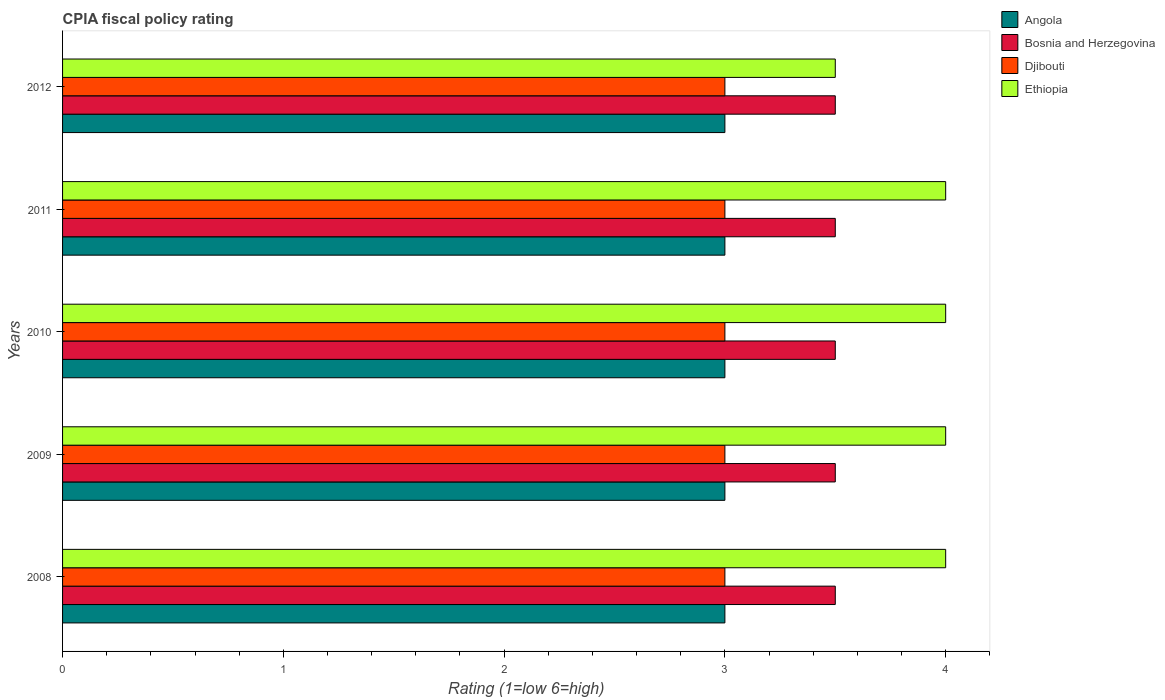How many different coloured bars are there?
Offer a terse response. 4. Are the number of bars per tick equal to the number of legend labels?
Your response must be concise. Yes. Are the number of bars on each tick of the Y-axis equal?
Your answer should be very brief. Yes. How many bars are there on the 5th tick from the top?
Provide a succinct answer. 4. How many bars are there on the 4th tick from the bottom?
Your answer should be compact. 4. What is the label of the 5th group of bars from the top?
Provide a short and direct response. 2008. What is the CPIA rating in Djibouti in 2012?
Provide a succinct answer. 3. Across all years, what is the maximum CPIA rating in Ethiopia?
Offer a very short reply. 4. In which year was the CPIA rating in Djibouti minimum?
Provide a short and direct response. 2008. What is the difference between the CPIA rating in Djibouti in 2010 and that in 2012?
Give a very brief answer. 0. What is the difference between the CPIA rating in Angola in 2009 and the CPIA rating in Ethiopia in 2008?
Offer a terse response. -1. What is the average CPIA rating in Angola per year?
Your response must be concise. 3. In how many years, is the CPIA rating in Djibouti greater than 3.2 ?
Make the answer very short. 0. Is the difference between the CPIA rating in Angola in 2008 and 2011 greater than the difference between the CPIA rating in Ethiopia in 2008 and 2011?
Make the answer very short. No. What is the difference between the highest and the second highest CPIA rating in Ethiopia?
Offer a very short reply. 0. What is the difference between the highest and the lowest CPIA rating in Angola?
Keep it short and to the point. 0. In how many years, is the CPIA rating in Bosnia and Herzegovina greater than the average CPIA rating in Bosnia and Herzegovina taken over all years?
Your response must be concise. 0. Is it the case that in every year, the sum of the CPIA rating in Angola and CPIA rating in Djibouti is greater than the sum of CPIA rating in Ethiopia and CPIA rating in Bosnia and Herzegovina?
Your answer should be compact. No. What does the 1st bar from the top in 2008 represents?
Your answer should be compact. Ethiopia. What does the 3rd bar from the bottom in 2012 represents?
Make the answer very short. Djibouti. Is it the case that in every year, the sum of the CPIA rating in Angola and CPIA rating in Ethiopia is greater than the CPIA rating in Bosnia and Herzegovina?
Your response must be concise. Yes. How many years are there in the graph?
Make the answer very short. 5. What is the difference between two consecutive major ticks on the X-axis?
Your answer should be very brief. 1. How many legend labels are there?
Offer a terse response. 4. What is the title of the graph?
Ensure brevity in your answer.  CPIA fiscal policy rating. Does "Papua New Guinea" appear as one of the legend labels in the graph?
Keep it short and to the point. No. What is the label or title of the X-axis?
Your answer should be compact. Rating (1=low 6=high). What is the Rating (1=low 6=high) of Angola in 2008?
Offer a terse response. 3. What is the Rating (1=low 6=high) in Angola in 2009?
Provide a short and direct response. 3. What is the Rating (1=low 6=high) in Djibouti in 2010?
Your answer should be compact. 3. What is the Rating (1=low 6=high) in Ethiopia in 2010?
Provide a short and direct response. 4. What is the Rating (1=low 6=high) of Angola in 2011?
Your answer should be very brief. 3. What is the Rating (1=low 6=high) of Djibouti in 2011?
Keep it short and to the point. 3. What is the Rating (1=low 6=high) in Angola in 2012?
Your response must be concise. 3. What is the Rating (1=low 6=high) of Djibouti in 2012?
Offer a very short reply. 3. Across all years, what is the maximum Rating (1=low 6=high) in Bosnia and Herzegovina?
Give a very brief answer. 3.5. Across all years, what is the maximum Rating (1=low 6=high) in Djibouti?
Make the answer very short. 3. Across all years, what is the minimum Rating (1=low 6=high) of Angola?
Keep it short and to the point. 3. Across all years, what is the minimum Rating (1=low 6=high) of Bosnia and Herzegovina?
Provide a short and direct response. 3.5. Across all years, what is the minimum Rating (1=low 6=high) in Djibouti?
Your answer should be compact. 3. Across all years, what is the minimum Rating (1=low 6=high) of Ethiopia?
Provide a succinct answer. 3.5. What is the total Rating (1=low 6=high) in Bosnia and Herzegovina in the graph?
Your answer should be compact. 17.5. What is the total Rating (1=low 6=high) in Djibouti in the graph?
Your response must be concise. 15. What is the difference between the Rating (1=low 6=high) in Ethiopia in 2008 and that in 2009?
Your response must be concise. 0. What is the difference between the Rating (1=low 6=high) in Angola in 2008 and that in 2010?
Keep it short and to the point. 0. What is the difference between the Rating (1=low 6=high) of Bosnia and Herzegovina in 2008 and that in 2010?
Ensure brevity in your answer.  0. What is the difference between the Rating (1=low 6=high) in Angola in 2008 and that in 2011?
Make the answer very short. 0. What is the difference between the Rating (1=low 6=high) of Djibouti in 2008 and that in 2012?
Give a very brief answer. 0. What is the difference between the Rating (1=low 6=high) of Ethiopia in 2008 and that in 2012?
Give a very brief answer. 0.5. What is the difference between the Rating (1=low 6=high) of Bosnia and Herzegovina in 2009 and that in 2010?
Provide a succinct answer. 0. What is the difference between the Rating (1=low 6=high) in Djibouti in 2009 and that in 2010?
Your response must be concise. 0. What is the difference between the Rating (1=low 6=high) of Ethiopia in 2009 and that in 2010?
Your answer should be compact. 0. What is the difference between the Rating (1=low 6=high) of Angola in 2009 and that in 2011?
Your answer should be compact. 0. What is the difference between the Rating (1=low 6=high) of Bosnia and Herzegovina in 2009 and that in 2011?
Provide a short and direct response. 0. What is the difference between the Rating (1=low 6=high) of Ethiopia in 2009 and that in 2012?
Your answer should be compact. 0.5. What is the difference between the Rating (1=low 6=high) in Angola in 2010 and that in 2011?
Give a very brief answer. 0. What is the difference between the Rating (1=low 6=high) of Djibouti in 2010 and that in 2011?
Your answer should be very brief. 0. What is the difference between the Rating (1=low 6=high) of Angola in 2010 and that in 2012?
Your answer should be compact. 0. What is the difference between the Rating (1=low 6=high) of Djibouti in 2011 and that in 2012?
Ensure brevity in your answer.  0. What is the difference between the Rating (1=low 6=high) of Ethiopia in 2011 and that in 2012?
Give a very brief answer. 0.5. What is the difference between the Rating (1=low 6=high) in Angola in 2008 and the Rating (1=low 6=high) in Bosnia and Herzegovina in 2009?
Your answer should be very brief. -0.5. What is the difference between the Rating (1=low 6=high) of Angola in 2008 and the Rating (1=low 6=high) of Djibouti in 2009?
Give a very brief answer. 0. What is the difference between the Rating (1=low 6=high) in Bosnia and Herzegovina in 2008 and the Rating (1=low 6=high) in Djibouti in 2009?
Your answer should be very brief. 0.5. What is the difference between the Rating (1=low 6=high) of Angola in 2008 and the Rating (1=low 6=high) of Djibouti in 2010?
Give a very brief answer. 0. What is the difference between the Rating (1=low 6=high) in Angola in 2008 and the Rating (1=low 6=high) in Ethiopia in 2010?
Offer a terse response. -1. What is the difference between the Rating (1=low 6=high) in Angola in 2008 and the Rating (1=low 6=high) in Djibouti in 2011?
Keep it short and to the point. 0. What is the difference between the Rating (1=low 6=high) of Bosnia and Herzegovina in 2008 and the Rating (1=low 6=high) of Djibouti in 2011?
Make the answer very short. 0.5. What is the difference between the Rating (1=low 6=high) of Bosnia and Herzegovina in 2008 and the Rating (1=low 6=high) of Ethiopia in 2011?
Provide a short and direct response. -0.5. What is the difference between the Rating (1=low 6=high) in Angola in 2008 and the Rating (1=low 6=high) in Bosnia and Herzegovina in 2012?
Offer a terse response. -0.5. What is the difference between the Rating (1=low 6=high) of Angola in 2008 and the Rating (1=low 6=high) of Ethiopia in 2012?
Your answer should be very brief. -0.5. What is the difference between the Rating (1=low 6=high) in Djibouti in 2008 and the Rating (1=low 6=high) in Ethiopia in 2012?
Provide a succinct answer. -0.5. What is the difference between the Rating (1=low 6=high) in Angola in 2009 and the Rating (1=low 6=high) in Ethiopia in 2010?
Provide a short and direct response. -1. What is the difference between the Rating (1=low 6=high) in Djibouti in 2009 and the Rating (1=low 6=high) in Ethiopia in 2010?
Your answer should be very brief. -1. What is the difference between the Rating (1=low 6=high) in Bosnia and Herzegovina in 2009 and the Rating (1=low 6=high) in Djibouti in 2011?
Give a very brief answer. 0.5. What is the difference between the Rating (1=low 6=high) of Bosnia and Herzegovina in 2009 and the Rating (1=low 6=high) of Ethiopia in 2011?
Provide a succinct answer. -0.5. What is the difference between the Rating (1=low 6=high) in Djibouti in 2009 and the Rating (1=low 6=high) in Ethiopia in 2011?
Offer a very short reply. -1. What is the difference between the Rating (1=low 6=high) in Angola in 2009 and the Rating (1=low 6=high) in Djibouti in 2012?
Offer a very short reply. 0. What is the difference between the Rating (1=low 6=high) of Bosnia and Herzegovina in 2009 and the Rating (1=low 6=high) of Ethiopia in 2012?
Your response must be concise. 0. What is the difference between the Rating (1=low 6=high) of Djibouti in 2009 and the Rating (1=low 6=high) of Ethiopia in 2012?
Your answer should be compact. -0.5. What is the difference between the Rating (1=low 6=high) of Angola in 2010 and the Rating (1=low 6=high) of Djibouti in 2011?
Ensure brevity in your answer.  0. What is the difference between the Rating (1=low 6=high) of Bosnia and Herzegovina in 2010 and the Rating (1=low 6=high) of Ethiopia in 2011?
Offer a very short reply. -0.5. What is the difference between the Rating (1=low 6=high) in Angola in 2010 and the Rating (1=low 6=high) in Bosnia and Herzegovina in 2012?
Provide a succinct answer. -0.5. What is the difference between the Rating (1=low 6=high) in Bosnia and Herzegovina in 2010 and the Rating (1=low 6=high) in Djibouti in 2012?
Offer a very short reply. 0.5. What is the difference between the Rating (1=low 6=high) in Angola in 2011 and the Rating (1=low 6=high) in Bosnia and Herzegovina in 2012?
Your answer should be compact. -0.5. What is the difference between the Rating (1=low 6=high) of Angola in 2011 and the Rating (1=low 6=high) of Ethiopia in 2012?
Your response must be concise. -0.5. What is the difference between the Rating (1=low 6=high) of Bosnia and Herzegovina in 2011 and the Rating (1=low 6=high) of Ethiopia in 2012?
Make the answer very short. 0. What is the difference between the Rating (1=low 6=high) in Djibouti in 2011 and the Rating (1=low 6=high) in Ethiopia in 2012?
Give a very brief answer. -0.5. In the year 2008, what is the difference between the Rating (1=low 6=high) of Angola and Rating (1=low 6=high) of Bosnia and Herzegovina?
Provide a succinct answer. -0.5. In the year 2008, what is the difference between the Rating (1=low 6=high) in Angola and Rating (1=low 6=high) in Djibouti?
Make the answer very short. 0. In the year 2008, what is the difference between the Rating (1=low 6=high) of Bosnia and Herzegovina and Rating (1=low 6=high) of Djibouti?
Give a very brief answer. 0.5. In the year 2008, what is the difference between the Rating (1=low 6=high) of Djibouti and Rating (1=low 6=high) of Ethiopia?
Provide a short and direct response. -1. In the year 2010, what is the difference between the Rating (1=low 6=high) of Angola and Rating (1=low 6=high) of Djibouti?
Your response must be concise. 0. In the year 2010, what is the difference between the Rating (1=low 6=high) in Bosnia and Herzegovina and Rating (1=low 6=high) in Ethiopia?
Offer a very short reply. -0.5. In the year 2010, what is the difference between the Rating (1=low 6=high) in Djibouti and Rating (1=low 6=high) in Ethiopia?
Offer a terse response. -1. In the year 2011, what is the difference between the Rating (1=low 6=high) in Angola and Rating (1=low 6=high) in Bosnia and Herzegovina?
Your answer should be compact. -0.5. In the year 2011, what is the difference between the Rating (1=low 6=high) in Bosnia and Herzegovina and Rating (1=low 6=high) in Ethiopia?
Ensure brevity in your answer.  -0.5. In the year 2011, what is the difference between the Rating (1=low 6=high) of Djibouti and Rating (1=low 6=high) of Ethiopia?
Offer a terse response. -1. In the year 2012, what is the difference between the Rating (1=low 6=high) of Angola and Rating (1=low 6=high) of Bosnia and Herzegovina?
Provide a short and direct response. -0.5. In the year 2012, what is the difference between the Rating (1=low 6=high) of Angola and Rating (1=low 6=high) of Djibouti?
Your answer should be very brief. 0. In the year 2012, what is the difference between the Rating (1=low 6=high) of Angola and Rating (1=low 6=high) of Ethiopia?
Your response must be concise. -0.5. In the year 2012, what is the difference between the Rating (1=low 6=high) in Bosnia and Herzegovina and Rating (1=low 6=high) in Djibouti?
Your answer should be compact. 0.5. In the year 2012, what is the difference between the Rating (1=low 6=high) in Bosnia and Herzegovina and Rating (1=low 6=high) in Ethiopia?
Make the answer very short. 0. In the year 2012, what is the difference between the Rating (1=low 6=high) of Djibouti and Rating (1=low 6=high) of Ethiopia?
Make the answer very short. -0.5. What is the ratio of the Rating (1=low 6=high) of Bosnia and Herzegovina in 2008 to that in 2009?
Ensure brevity in your answer.  1. What is the ratio of the Rating (1=low 6=high) in Ethiopia in 2008 to that in 2009?
Your response must be concise. 1. What is the ratio of the Rating (1=low 6=high) of Djibouti in 2008 to that in 2010?
Your answer should be compact. 1. What is the ratio of the Rating (1=low 6=high) in Ethiopia in 2008 to that in 2010?
Provide a short and direct response. 1. What is the ratio of the Rating (1=low 6=high) of Bosnia and Herzegovina in 2008 to that in 2011?
Your answer should be compact. 1. What is the ratio of the Rating (1=low 6=high) in Djibouti in 2008 to that in 2011?
Your answer should be compact. 1. What is the ratio of the Rating (1=low 6=high) of Ethiopia in 2008 to that in 2012?
Offer a very short reply. 1.14. What is the ratio of the Rating (1=low 6=high) of Angola in 2009 to that in 2010?
Keep it short and to the point. 1. What is the ratio of the Rating (1=low 6=high) of Bosnia and Herzegovina in 2009 to that in 2010?
Keep it short and to the point. 1. What is the ratio of the Rating (1=low 6=high) in Ethiopia in 2009 to that in 2010?
Offer a terse response. 1. What is the ratio of the Rating (1=low 6=high) in Djibouti in 2009 to that in 2011?
Keep it short and to the point. 1. What is the ratio of the Rating (1=low 6=high) of Ethiopia in 2009 to that in 2011?
Ensure brevity in your answer.  1. What is the ratio of the Rating (1=low 6=high) of Angola in 2009 to that in 2012?
Your answer should be very brief. 1. What is the ratio of the Rating (1=low 6=high) of Djibouti in 2009 to that in 2012?
Provide a succinct answer. 1. What is the ratio of the Rating (1=low 6=high) of Ethiopia in 2009 to that in 2012?
Ensure brevity in your answer.  1.14. What is the ratio of the Rating (1=low 6=high) in Angola in 2010 to that in 2011?
Offer a terse response. 1. What is the ratio of the Rating (1=low 6=high) of Ethiopia in 2010 to that in 2011?
Ensure brevity in your answer.  1. What is the ratio of the Rating (1=low 6=high) in Angola in 2011 to that in 2012?
Ensure brevity in your answer.  1. What is the ratio of the Rating (1=low 6=high) in Djibouti in 2011 to that in 2012?
Offer a very short reply. 1. What is the difference between the highest and the second highest Rating (1=low 6=high) of Angola?
Keep it short and to the point. 0. What is the difference between the highest and the lowest Rating (1=low 6=high) in Angola?
Offer a very short reply. 0. 